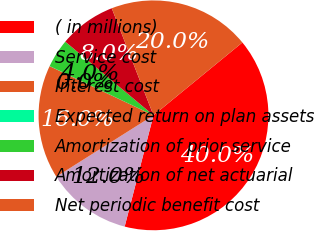Convert chart. <chart><loc_0><loc_0><loc_500><loc_500><pie_chart><fcel>( in millions)<fcel>Service cost<fcel>Interest cost<fcel>Expected return on plan assets<fcel>Amortization of prior service<fcel>Amortization of net actuarial<fcel>Net periodic benefit cost<nl><fcel>39.96%<fcel>12.0%<fcel>16.0%<fcel>0.02%<fcel>4.02%<fcel>8.01%<fcel>19.99%<nl></chart> 